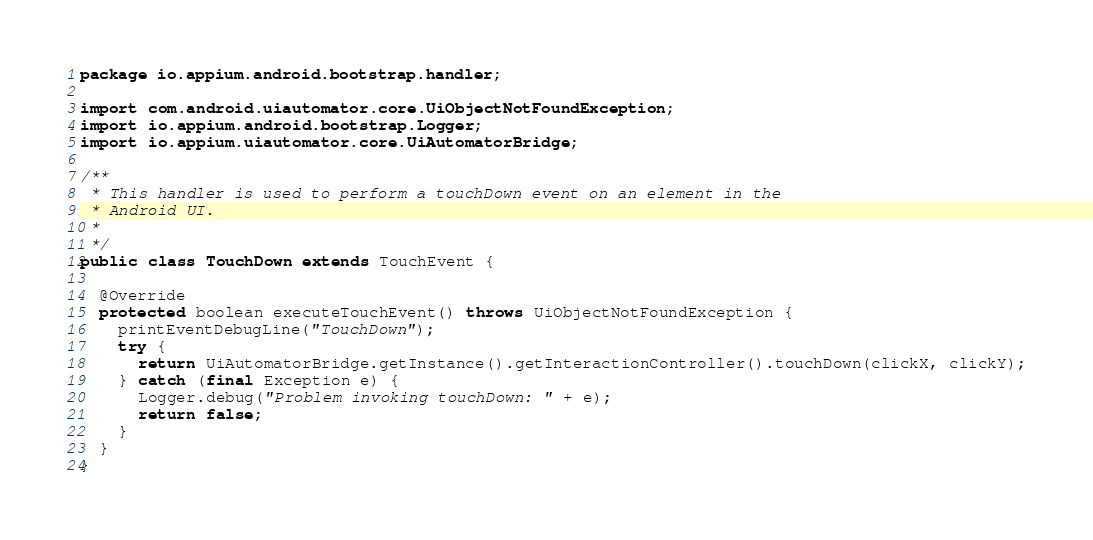Convert code to text. <code><loc_0><loc_0><loc_500><loc_500><_Java_>package io.appium.android.bootstrap.handler;

import com.android.uiautomator.core.UiObjectNotFoundException;
import io.appium.android.bootstrap.Logger;
import io.appium.uiautomator.core.UiAutomatorBridge;

/**
 * This handler is used to perform a touchDown event on an element in the
 * Android UI.
 * 
 */
public class TouchDown extends TouchEvent {

  @Override
  protected boolean executeTouchEvent() throws UiObjectNotFoundException {
    printEventDebugLine("TouchDown");
    try {
      return UiAutomatorBridge.getInstance().getInteractionController().touchDown(clickX, clickY);
    } catch (final Exception e) {
      Logger.debug("Problem invoking touchDown: " + e);
      return false;
    }
  }
}</code> 